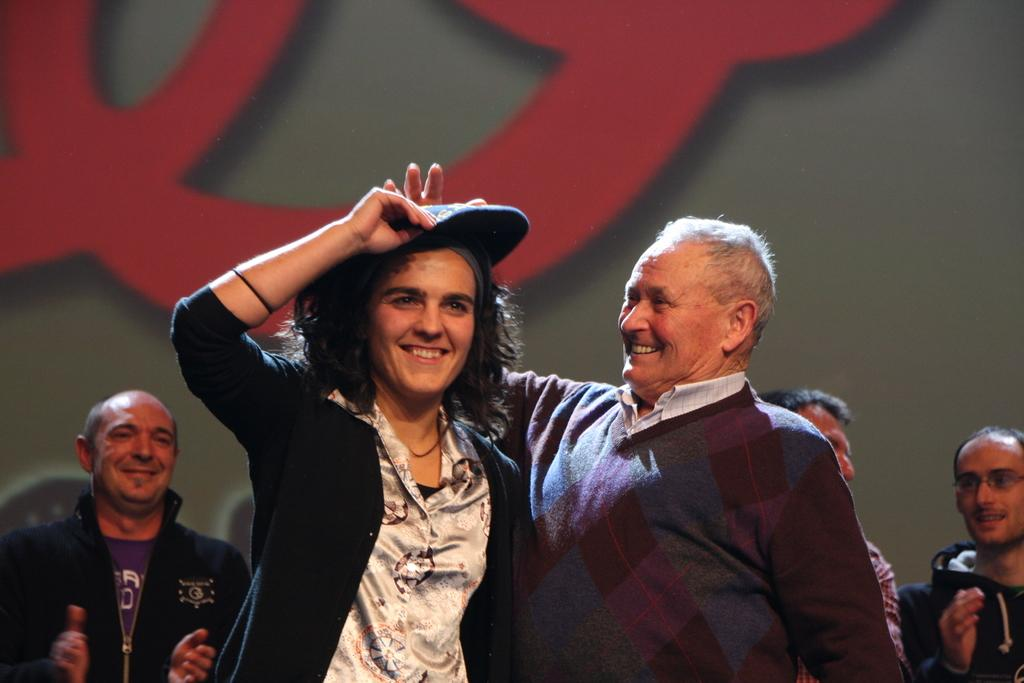How many people are in the image? There are persons standing in the image. What is on one of the person's heads? There is an object on a person's head in the image. Can you describe the background of the image? There is an object in the background of the image. What type of monkey can be seen participating in the voyage in the image? There is no monkey or voyage present in the image. What boundary is visible in the image? There is no boundary visible in the image. 